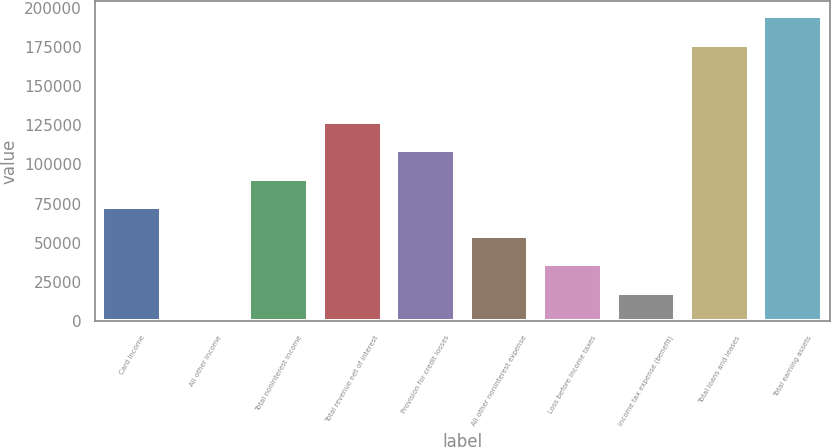Convert chart to OTSL. <chart><loc_0><loc_0><loc_500><loc_500><bar_chart><fcel>Card income<fcel>All other income<fcel>Total noninterest income<fcel>Total revenue net of interest<fcel>Provision for credit losses<fcel>All other noninterest expense<fcel>Loss before income taxes<fcel>Income tax expense (benefit)<fcel>Total loans and leases<fcel>Total earning assets<nl><fcel>72791.6<fcel>142<fcel>90954<fcel>127279<fcel>109116<fcel>54629.2<fcel>36466.8<fcel>18304.4<fcel>176232<fcel>194394<nl></chart> 